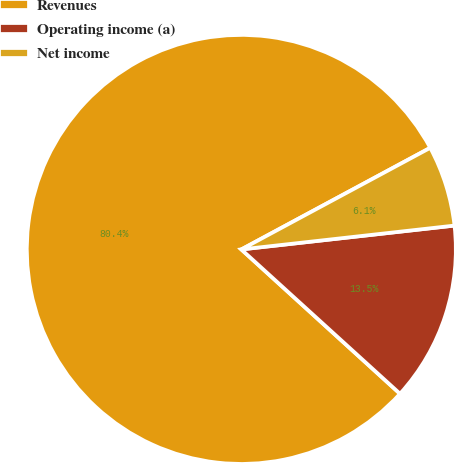<chart> <loc_0><loc_0><loc_500><loc_500><pie_chart><fcel>Revenues<fcel>Operating income (a)<fcel>Net income<nl><fcel>80.4%<fcel>13.52%<fcel>6.08%<nl></chart> 